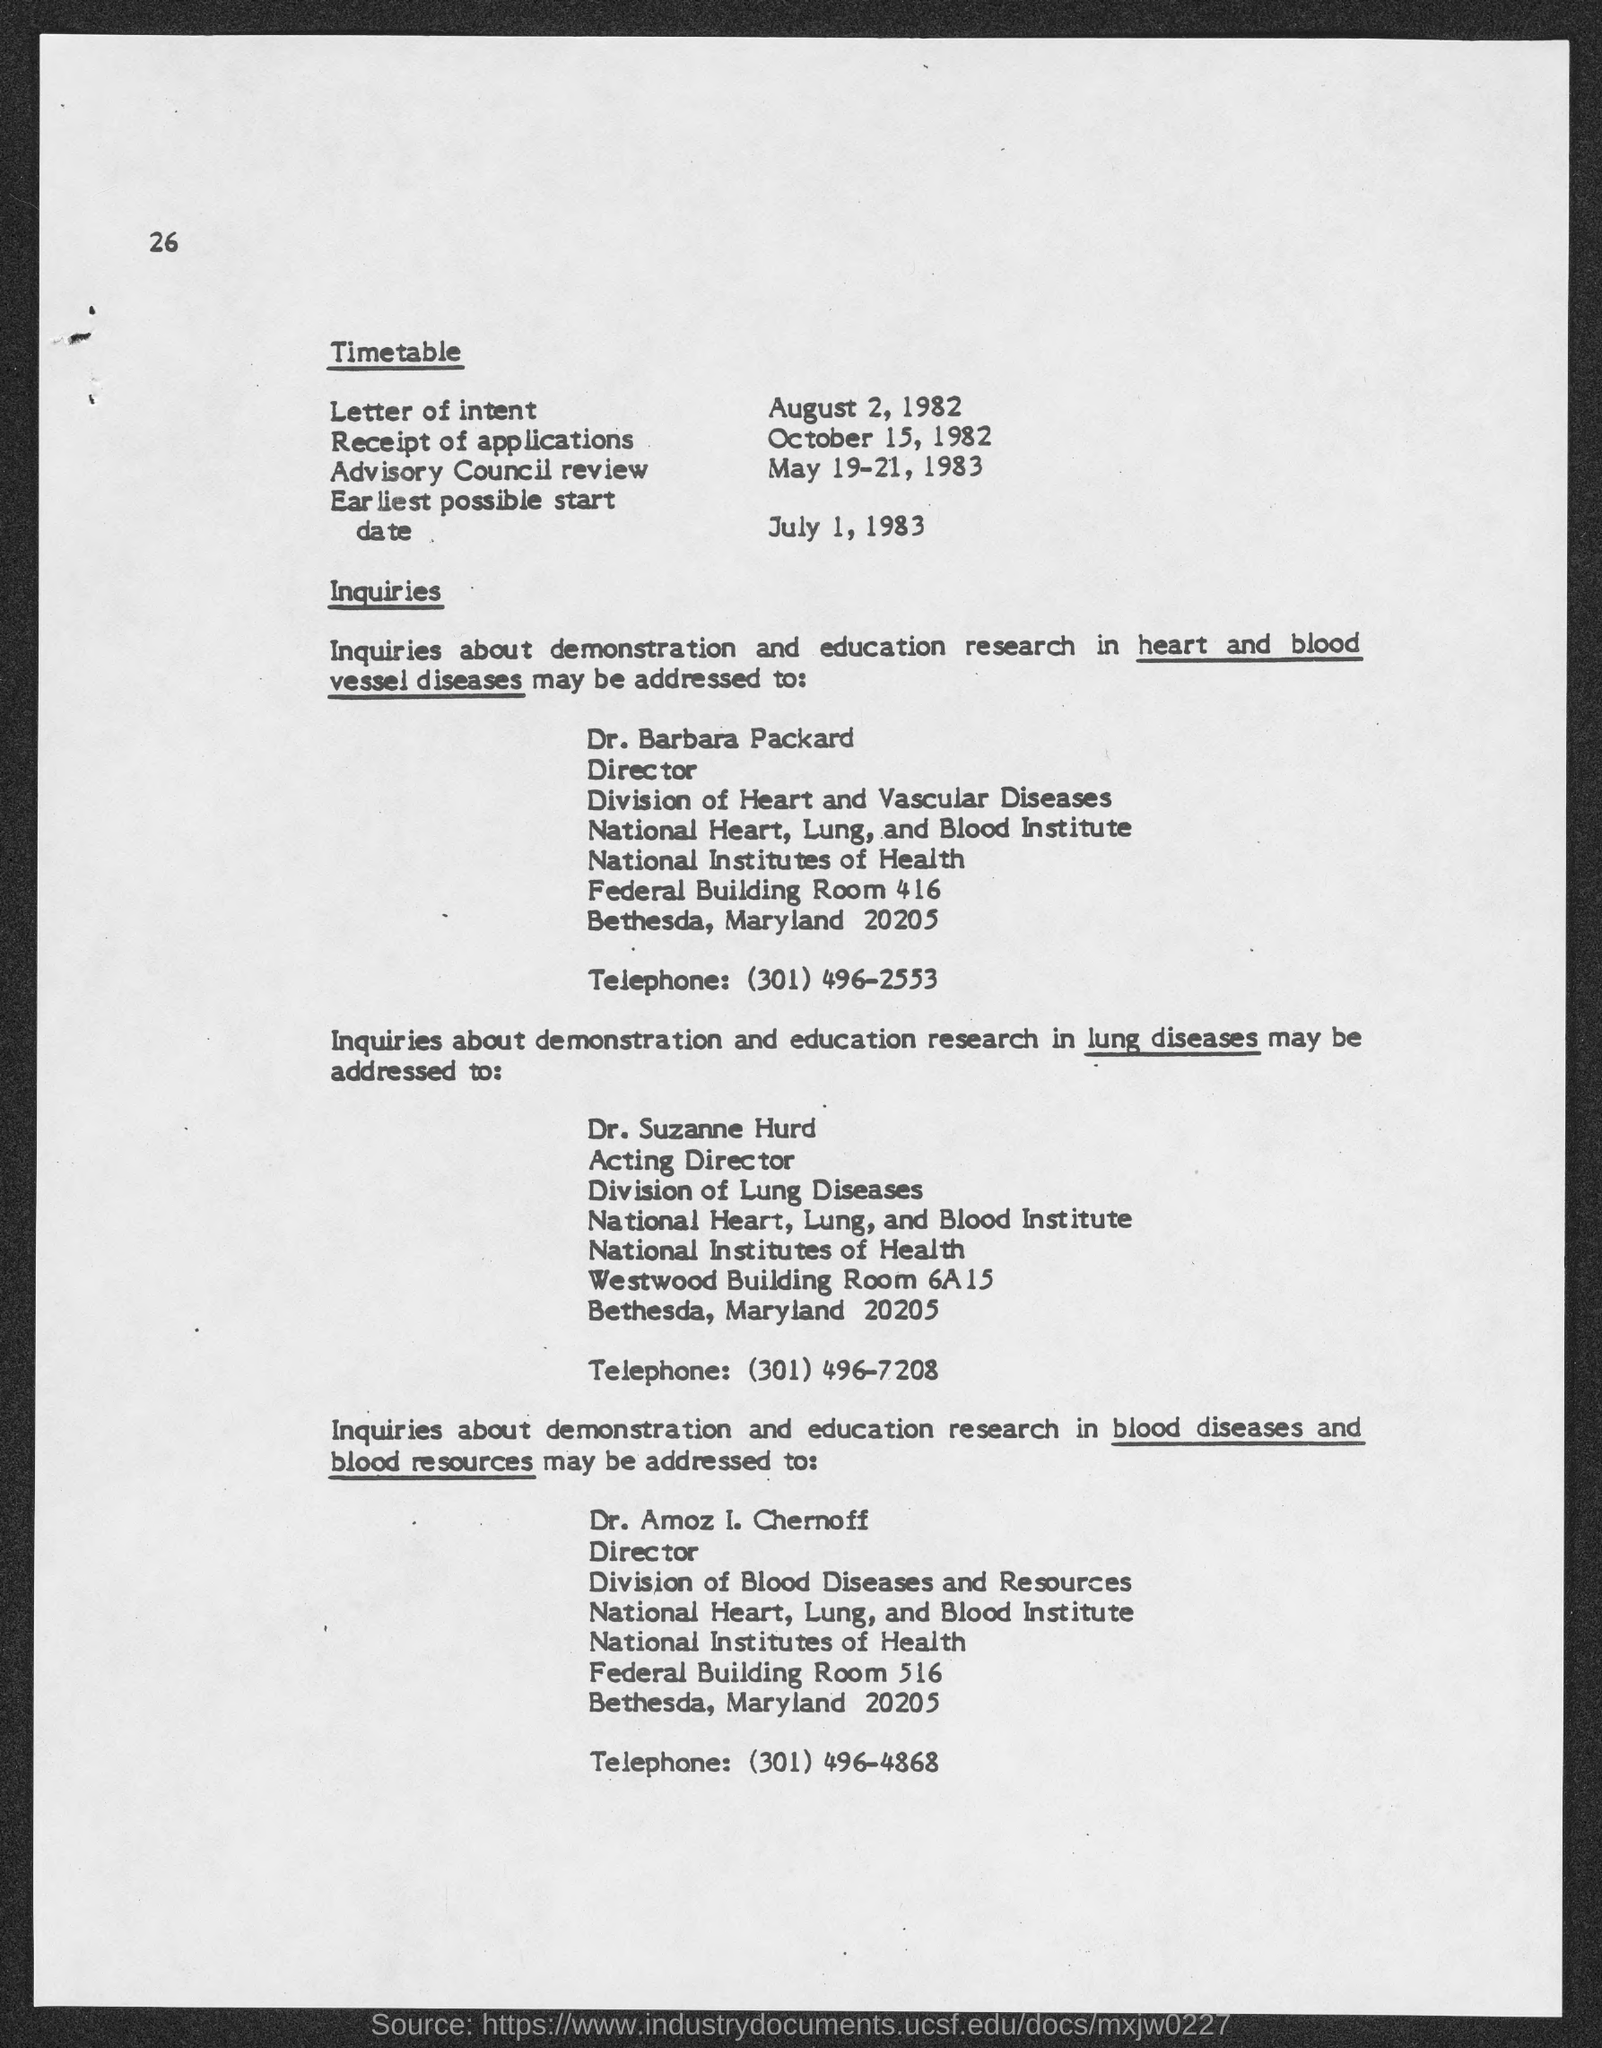What is the position of dr. barbara packard ?
Provide a short and direct response. Director. To whom must inquiries  about demonstration and education research in heart and blood vessel diseases may be addressed ?
Provide a succinct answer. Dr. Barbara Packard. To whom inquiries about demonstration and education research in lung diseases may be addressed ?
Make the answer very short. Suzanne Hurd. What is the position of dr. suzanne hurd ?
Offer a very short reply. Acting director. What is the telephone number of dr. suzanne hurd?
Your answer should be compact. (301) 496-7208. To whom inquiries about demonstration and education research in blood diseases and blood resources may be addressed ?
Offer a terse response. Amoz I. Chernoff. What is the position of dr. amoz i. chernoff ?
Provide a short and direct response. Director. 